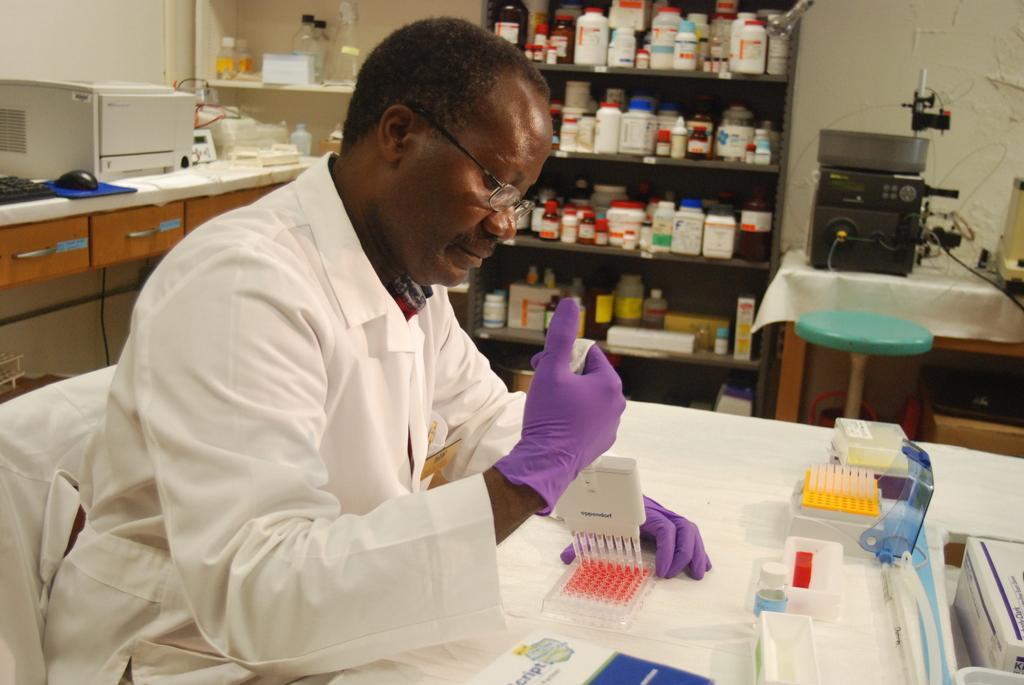Can you describe this image briefly? There is a person wearing specs and gloves is holding something in the hand. He is sitting on a chair. Also there is a table. On the table there is a box and many other items. On the left side there is a platform with drawers. On that there is an electronic device, keyboard, mouse and many other items. In the back there are cupboards with bottles and many other items. On the right side there is a table. On that there is an electronic device. Near to that there is a stool. 